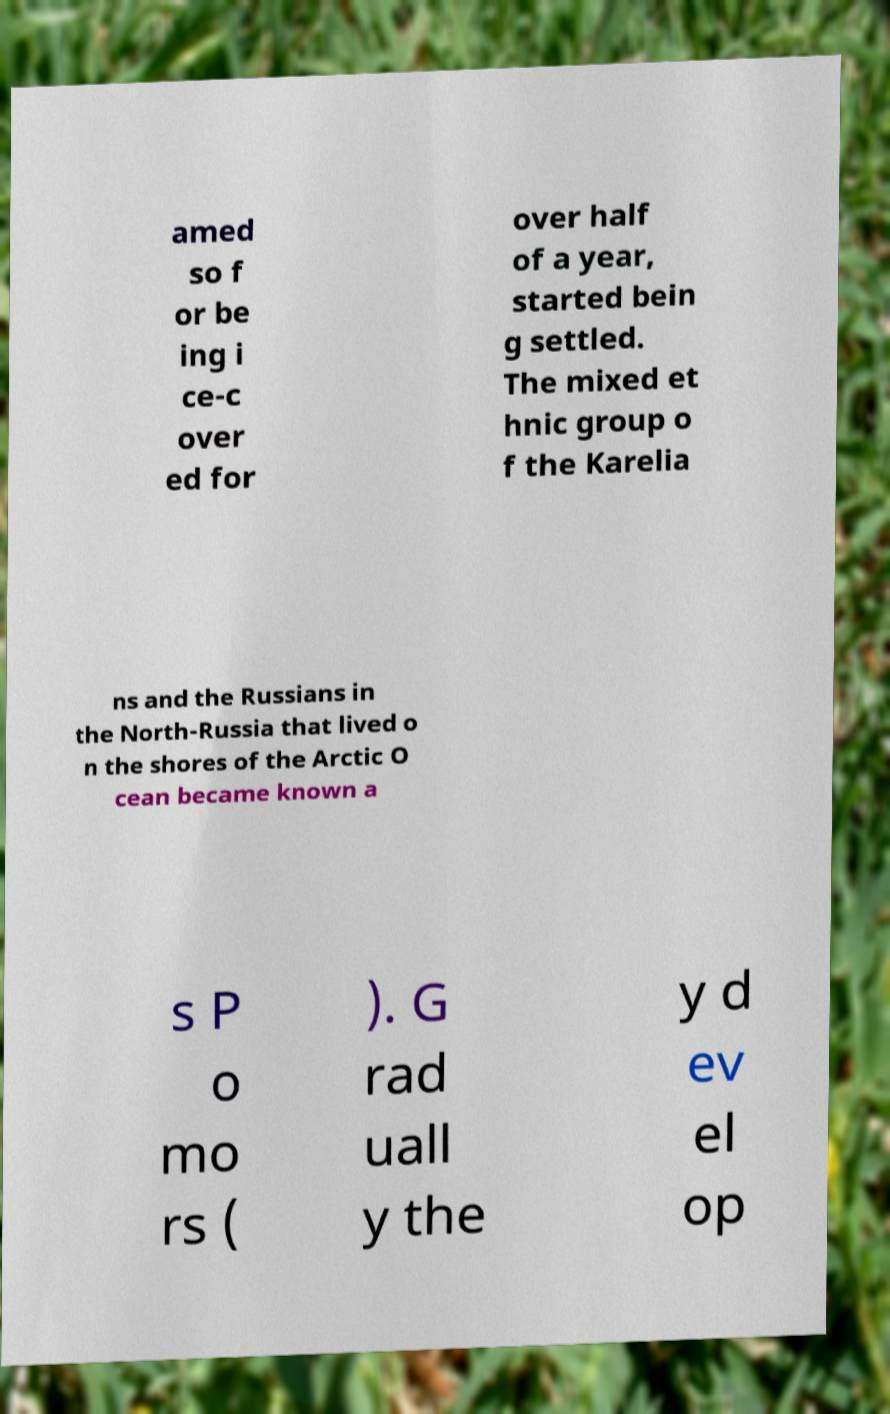I need the written content from this picture converted into text. Can you do that? amed so f or be ing i ce-c over ed for over half of a year, started bein g settled. The mixed et hnic group o f the Karelia ns and the Russians in the North-Russia that lived o n the shores of the Arctic O cean became known a s P o mo rs ( ). G rad uall y the y d ev el op 